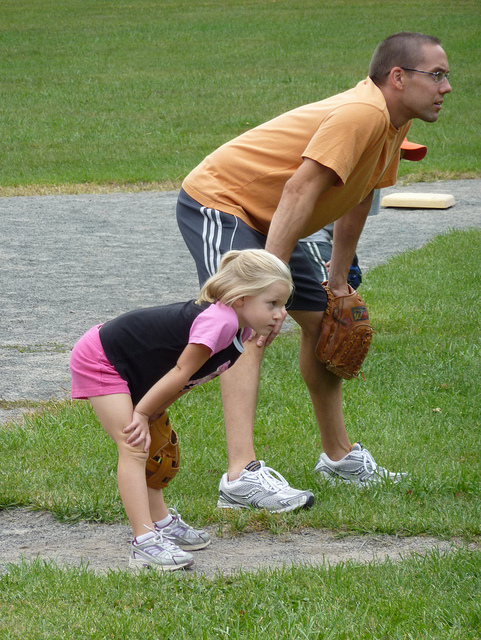What activity are the two individuals engaged in? The adult and child appear to be playing catch or preparing to play a ball game, as suggested by their focused stances and the baseball mitt the adult is wearing. 